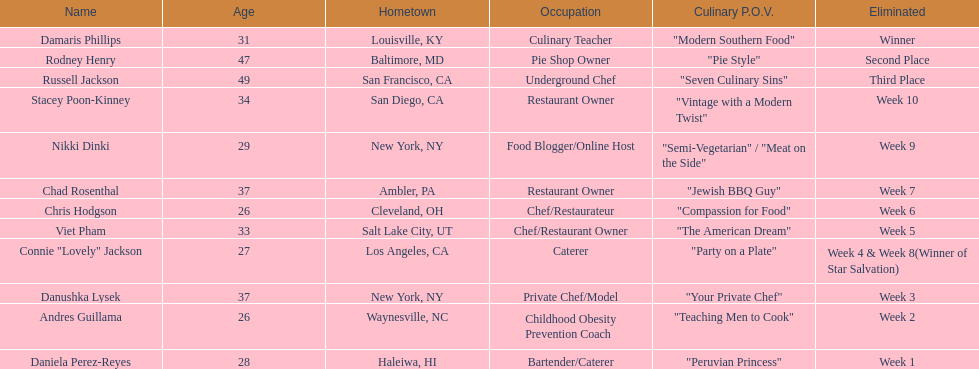Whose culinary perspective was described more extensively than "vintage with a modern twist" among the contestants? Nikki Dinki. Write the full table. {'header': ['Name', 'Age', 'Hometown', 'Occupation', 'Culinary P.O.V.', 'Eliminated'], 'rows': [['Damaris Phillips', '31', 'Louisville, KY', 'Culinary Teacher', '"Modern Southern Food"', 'Winner'], ['Rodney Henry', '47', 'Baltimore, MD', 'Pie Shop Owner', '"Pie Style"', 'Second Place'], ['Russell Jackson', '49', 'San Francisco, CA', 'Underground Chef', '"Seven Culinary Sins"', 'Third Place'], ['Stacey Poon-Kinney', '34', 'San Diego, CA', 'Restaurant Owner', '"Vintage with a Modern Twist"', 'Week 10'], ['Nikki Dinki', '29', 'New York, NY', 'Food Blogger/Online Host', '"Semi-Vegetarian" / "Meat on the Side"', 'Week 9'], ['Chad Rosenthal', '37', 'Ambler, PA', 'Restaurant Owner', '"Jewish BBQ Guy"', 'Week 7'], ['Chris Hodgson', '26', 'Cleveland, OH', 'Chef/Restaurateur', '"Compassion for Food"', 'Week 6'], ['Viet Pham', '33', 'Salt Lake City, UT', 'Chef/Restaurant Owner', '"The American Dream"', 'Week 5'], ['Connie "Lovely" Jackson', '27', 'Los Angeles, CA', 'Caterer', '"Party on a Plate"', 'Week 4 & Week 8(Winner of Star Salvation)'], ['Danushka Lysek', '37', 'New York, NY', 'Private Chef/Model', '"Your Private Chef"', 'Week 3'], ['Andres Guillama', '26', 'Waynesville, NC', 'Childhood Obesity Prevention Coach', '"Teaching Men to Cook"', 'Week 2'], ['Daniela Perez-Reyes', '28', 'Haleiwa, HI', 'Bartender/Caterer', '"Peruvian Princess"', 'Week 1']]} 